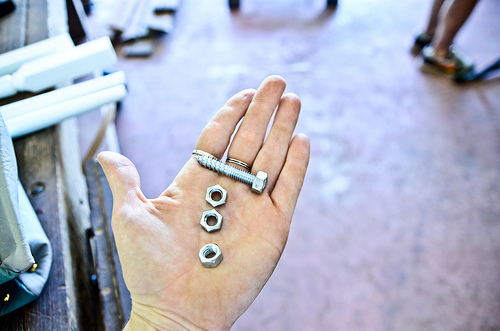<image>
Is the screw in the nut? No. The screw is not contained within the nut. These objects have a different spatial relationship. 